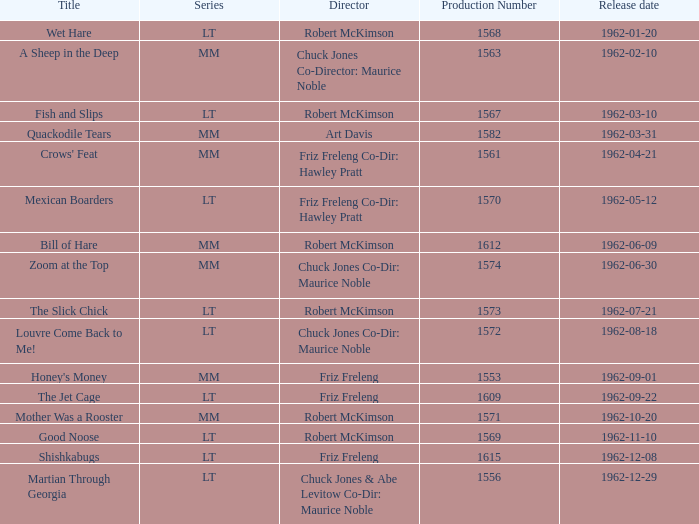What is the production number of crows' feat? 1561.0. 